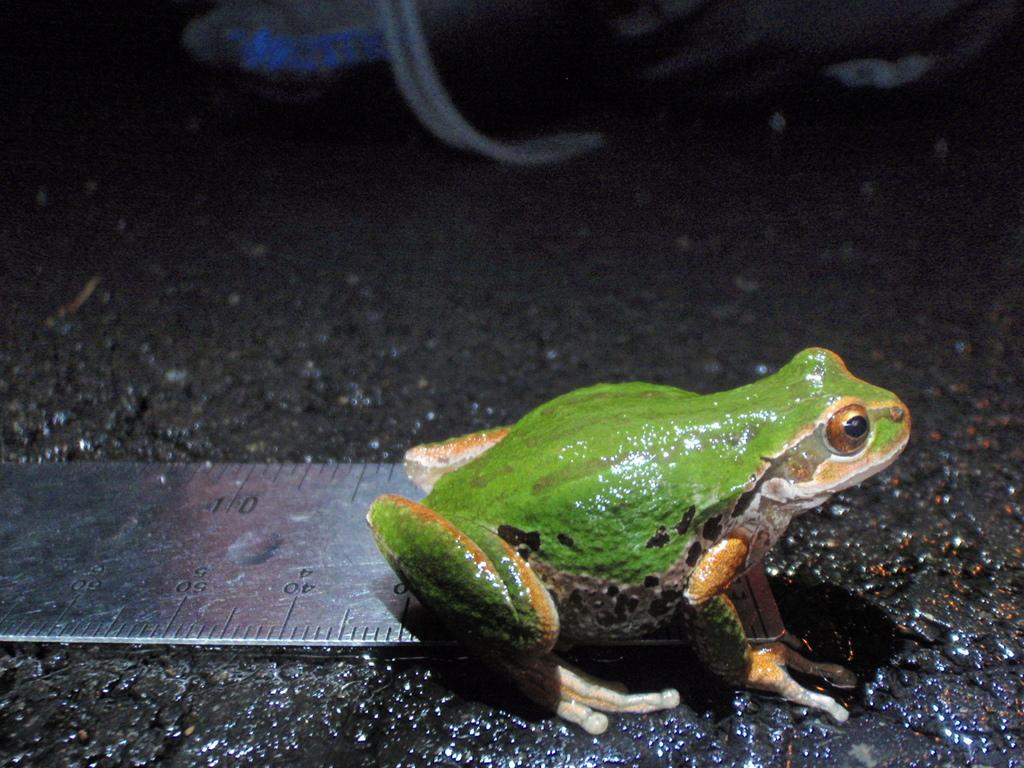What type of animal is in the image? There is a frog in the image. What colors can be seen on the frog? The frog has green, black, brown, and orange colors. What object is present in the image that is typically used for weighing things? There is a metal scale in the image. What color is the ground in the image? The ground is black in color. How much rice is being weighed on the metal scale in the image? There is no rice present in the image; it features a frog and a metal scale, but no rice. What type of headwear is the frog wearing in the image? The frog is not wearing any headwear in the image. 